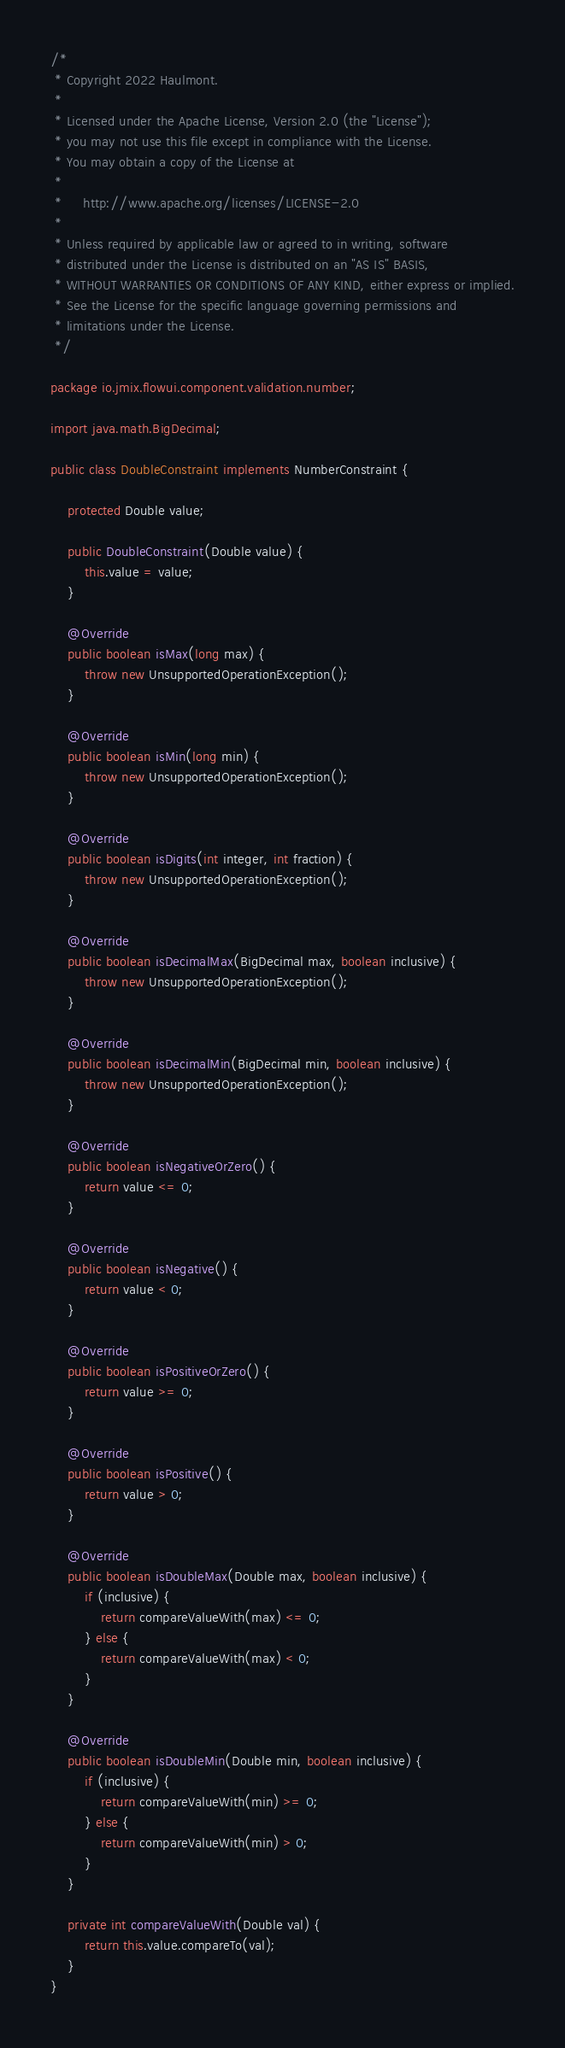<code> <loc_0><loc_0><loc_500><loc_500><_Java_>/*
 * Copyright 2022 Haulmont.
 *
 * Licensed under the Apache License, Version 2.0 (the "License");
 * you may not use this file except in compliance with the License.
 * You may obtain a copy of the License at
 *
 *     http://www.apache.org/licenses/LICENSE-2.0
 *
 * Unless required by applicable law or agreed to in writing, software
 * distributed under the License is distributed on an "AS IS" BASIS,
 * WITHOUT WARRANTIES OR CONDITIONS OF ANY KIND, either express or implied.
 * See the License for the specific language governing permissions and
 * limitations under the License.
 */

package io.jmix.flowui.component.validation.number;

import java.math.BigDecimal;

public class DoubleConstraint implements NumberConstraint {

    protected Double value;

    public DoubleConstraint(Double value) {
        this.value = value;
    }

    @Override
    public boolean isMax(long max) {
        throw new UnsupportedOperationException();
    }

    @Override
    public boolean isMin(long min) {
        throw new UnsupportedOperationException();
    }

    @Override
    public boolean isDigits(int integer, int fraction) {
        throw new UnsupportedOperationException();
    }

    @Override
    public boolean isDecimalMax(BigDecimal max, boolean inclusive) {
        throw new UnsupportedOperationException();
    }

    @Override
    public boolean isDecimalMin(BigDecimal min, boolean inclusive) {
        throw new UnsupportedOperationException();
    }

    @Override
    public boolean isNegativeOrZero() {
        return value <= 0;
    }

    @Override
    public boolean isNegative() {
        return value < 0;
    }

    @Override
    public boolean isPositiveOrZero() {
        return value >= 0;
    }

    @Override
    public boolean isPositive() {
        return value > 0;
    }

    @Override
    public boolean isDoubleMax(Double max, boolean inclusive) {
        if (inclusive) {
            return compareValueWith(max) <= 0;
        } else {
            return compareValueWith(max) < 0;
        }
    }

    @Override
    public boolean isDoubleMin(Double min, boolean inclusive) {
        if (inclusive) {
            return compareValueWith(min) >= 0;
        } else {
            return compareValueWith(min) > 0;
        }
    }

    private int compareValueWith(Double val) {
        return this.value.compareTo(val);
    }
}
</code> 